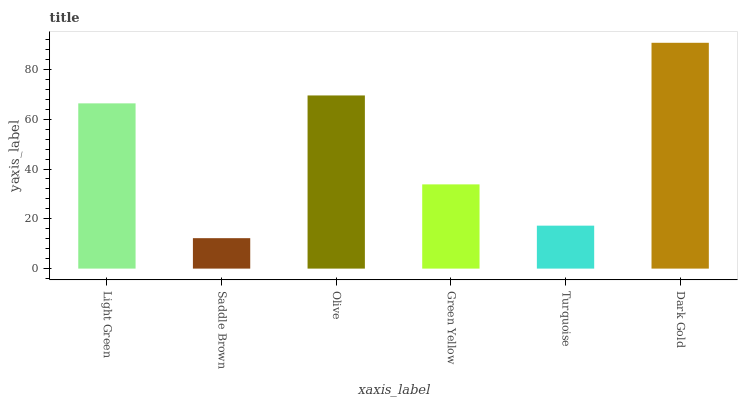Is Saddle Brown the minimum?
Answer yes or no. Yes. Is Dark Gold the maximum?
Answer yes or no. Yes. Is Olive the minimum?
Answer yes or no. No. Is Olive the maximum?
Answer yes or no. No. Is Olive greater than Saddle Brown?
Answer yes or no. Yes. Is Saddle Brown less than Olive?
Answer yes or no. Yes. Is Saddle Brown greater than Olive?
Answer yes or no. No. Is Olive less than Saddle Brown?
Answer yes or no. No. Is Light Green the high median?
Answer yes or no. Yes. Is Green Yellow the low median?
Answer yes or no. Yes. Is Turquoise the high median?
Answer yes or no. No. Is Olive the low median?
Answer yes or no. No. 